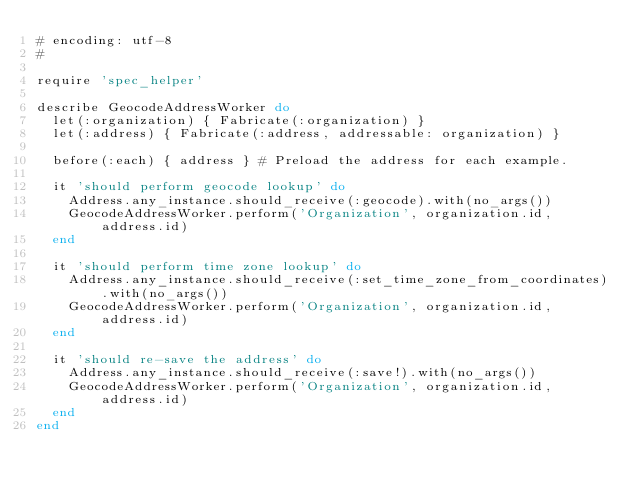<code> <loc_0><loc_0><loc_500><loc_500><_Ruby_># encoding: utf-8
#

require 'spec_helper'

describe GeocodeAddressWorker do
  let(:organization) { Fabricate(:organization) }
  let(:address) { Fabricate(:address, addressable: organization) }

  before(:each) { address } # Preload the address for each example.

  it 'should perform geocode lookup' do
    Address.any_instance.should_receive(:geocode).with(no_args())
    GeocodeAddressWorker.perform('Organization', organization.id, address.id)
  end

  it 'should perform time zone lookup' do
    Address.any_instance.should_receive(:set_time_zone_from_coordinates).with(no_args())
    GeocodeAddressWorker.perform('Organization', organization.id, address.id)
  end

  it 'should re-save the address' do
    Address.any_instance.should_receive(:save!).with(no_args())
    GeocodeAddressWorker.perform('Organization', organization.id, address.id)
  end
end
</code> 